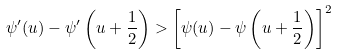<formula> <loc_0><loc_0><loc_500><loc_500>\psi ^ { \prime } ( u ) - \psi ^ { \prime } \left ( u + \frac { 1 } { 2 } \right ) > \left [ \psi ( u ) - \psi \left ( u + \frac { 1 } { 2 } \right ) \right ] ^ { 2 }</formula> 